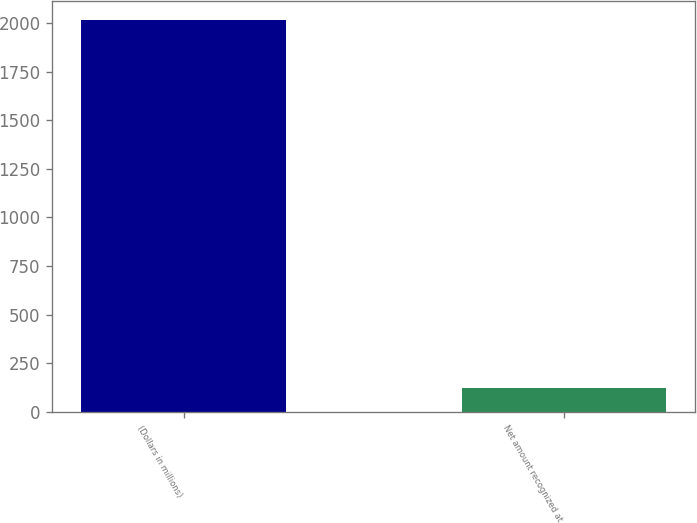Convert chart to OTSL. <chart><loc_0><loc_0><loc_500><loc_500><bar_chart><fcel>(Dollars in millions)<fcel>Net amount recognized at<nl><fcel>2014<fcel>124<nl></chart> 